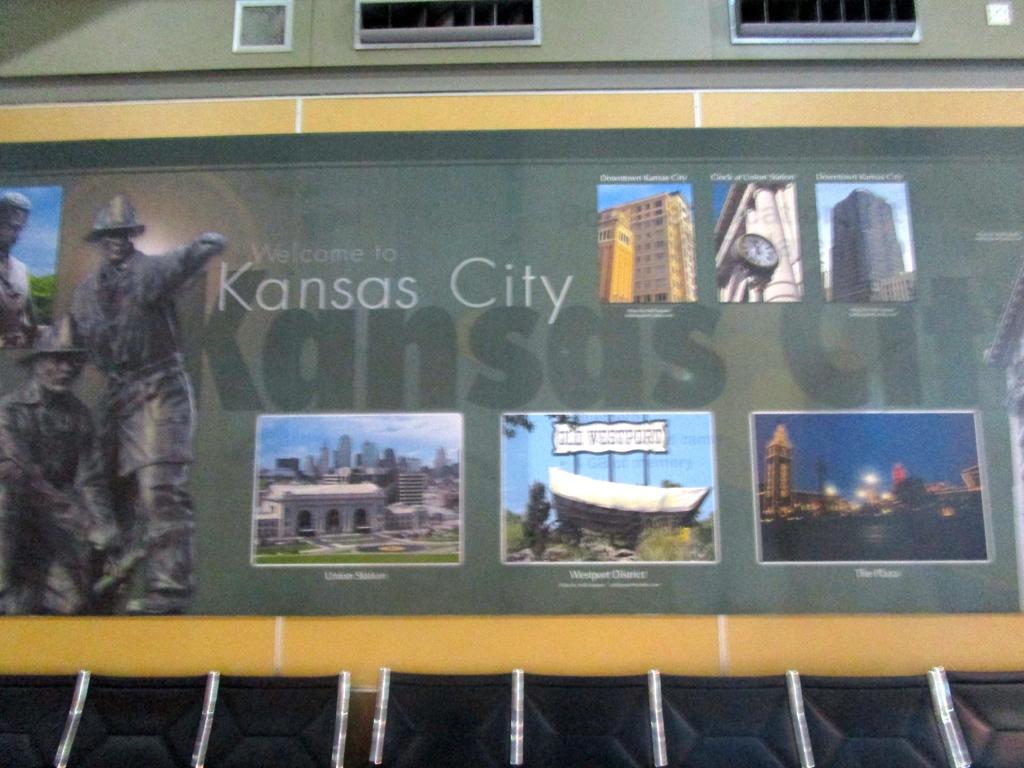What city is this in?
Provide a short and direct response. Kansas city. 